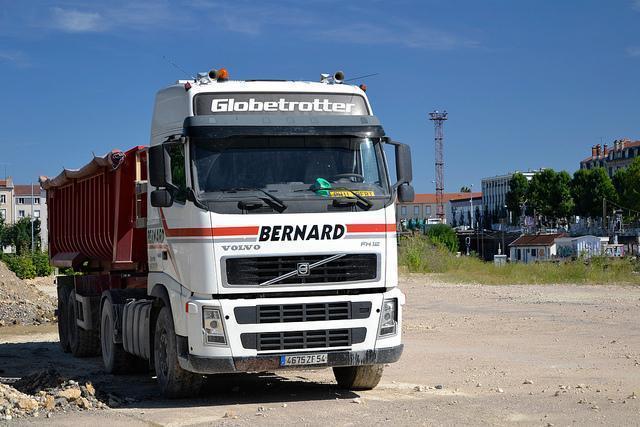This truck shares a name with a popular American Sporting expo group who plays what sport?
From the following four choices, select the correct answer to address the question.
Options: Soccer, tennis, baseball, basketball. Basketball. 